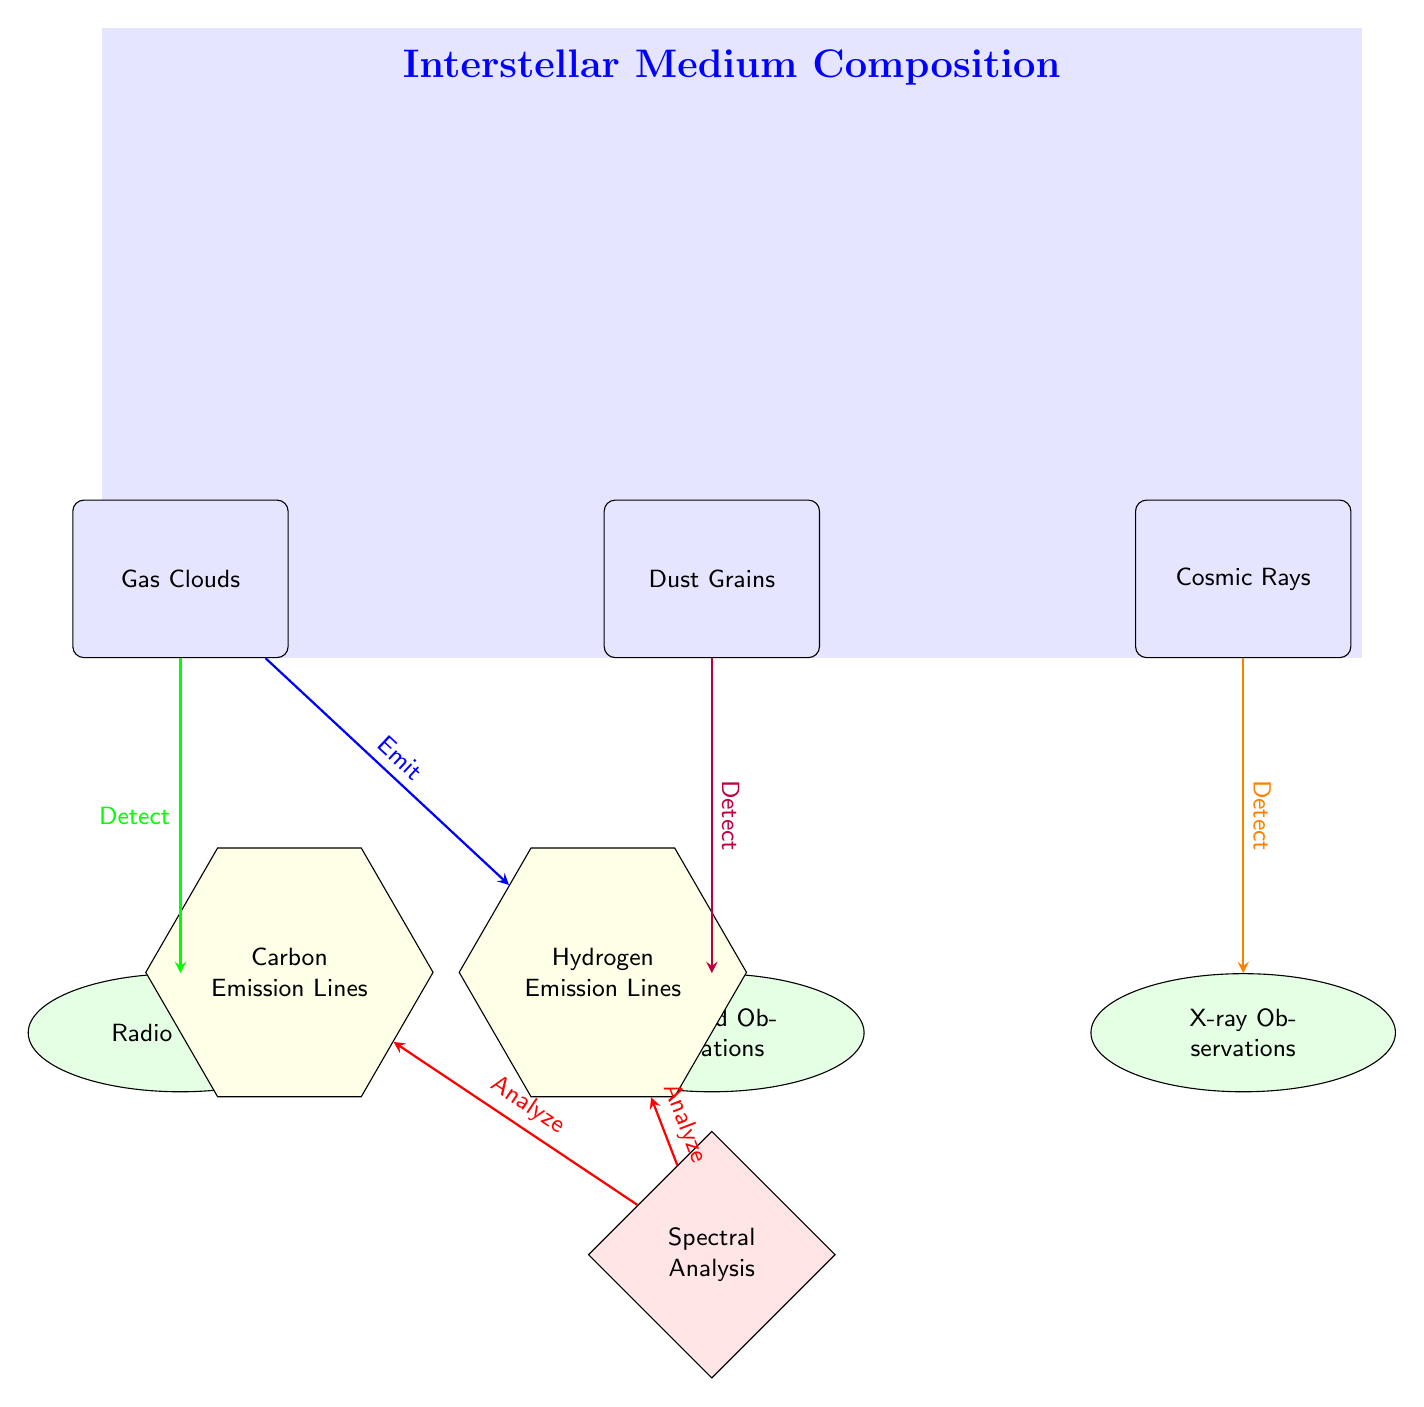What are the three main components of the interstellar medium shown in the diagram? The diagram explicitly lists three components: Gas Clouds, Dust Grains, and Cosmic Rays. These are individual nodes answering the question in a straightforward manner.
Answer: Gas Clouds, Dust Grains, Cosmic Rays Which observation is related to Dust Grains? In the diagram, Dust Grains have an arrow leading to "Infrared Observations," indicating a direct relationship between these two elements where infrared observations are used to study dust grains.
Answer: Infrared Observations How many types of emissions are depicted in the diagram? The diagram shows two emissions related to the components: Hydrogen Emission Lines (connected to Gas Clouds) and Carbon Emission Lines (connected to Dust Grains). Counting these nodes provides the answer.
Answer: 2 What is the connection between Cosmic Rays and X-ray Observations? The diagram indicates that Cosmic Rays are detected through X-ray Observations, as shown by an arrow leading from Cosmic Rays to X-ray Observations, establishing a detection relationship.
Answer: Detect What type of analysis is conducted in relation to the components? The diagram shows that "Spectral Analysis" is performed on both Hydrogen and Carbon emissions, suggesting that these emissions are analyzed spectrally, serving as the type of analysis mentioned in the context.
Answer: Spectral Analysis 